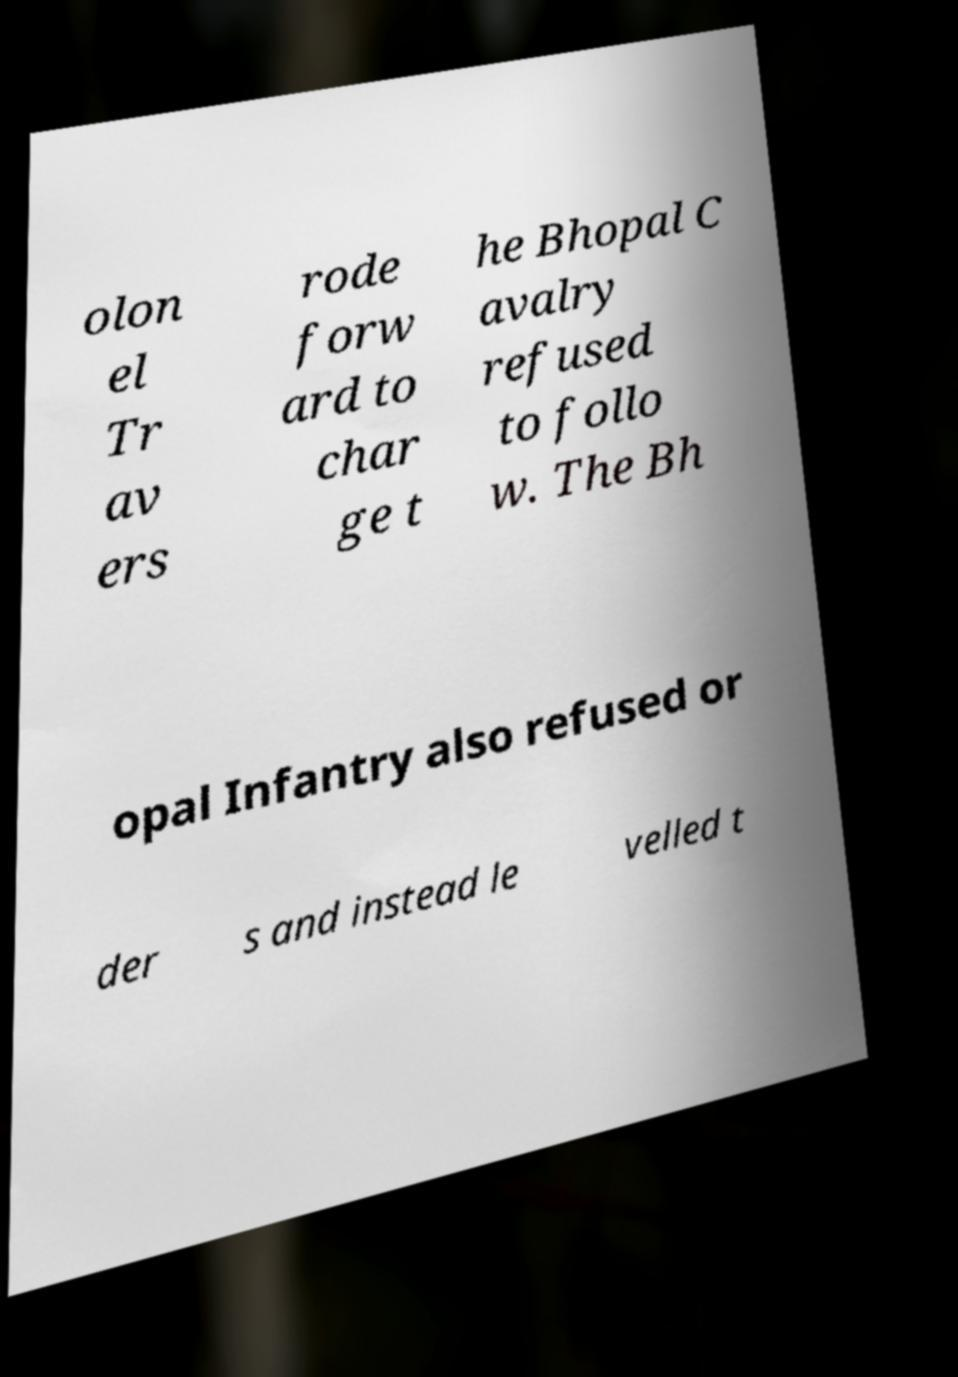Please identify and transcribe the text found in this image. olon el Tr av ers rode forw ard to char ge t he Bhopal C avalry refused to follo w. The Bh opal Infantry also refused or der s and instead le velled t 